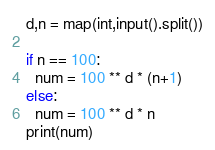<code> <loc_0><loc_0><loc_500><loc_500><_Python_>d,n = map(int,input().split())

if n == 100:
  num = 100 ** d * (n+1)
else:
  num = 100 ** d * n
print(num)</code> 